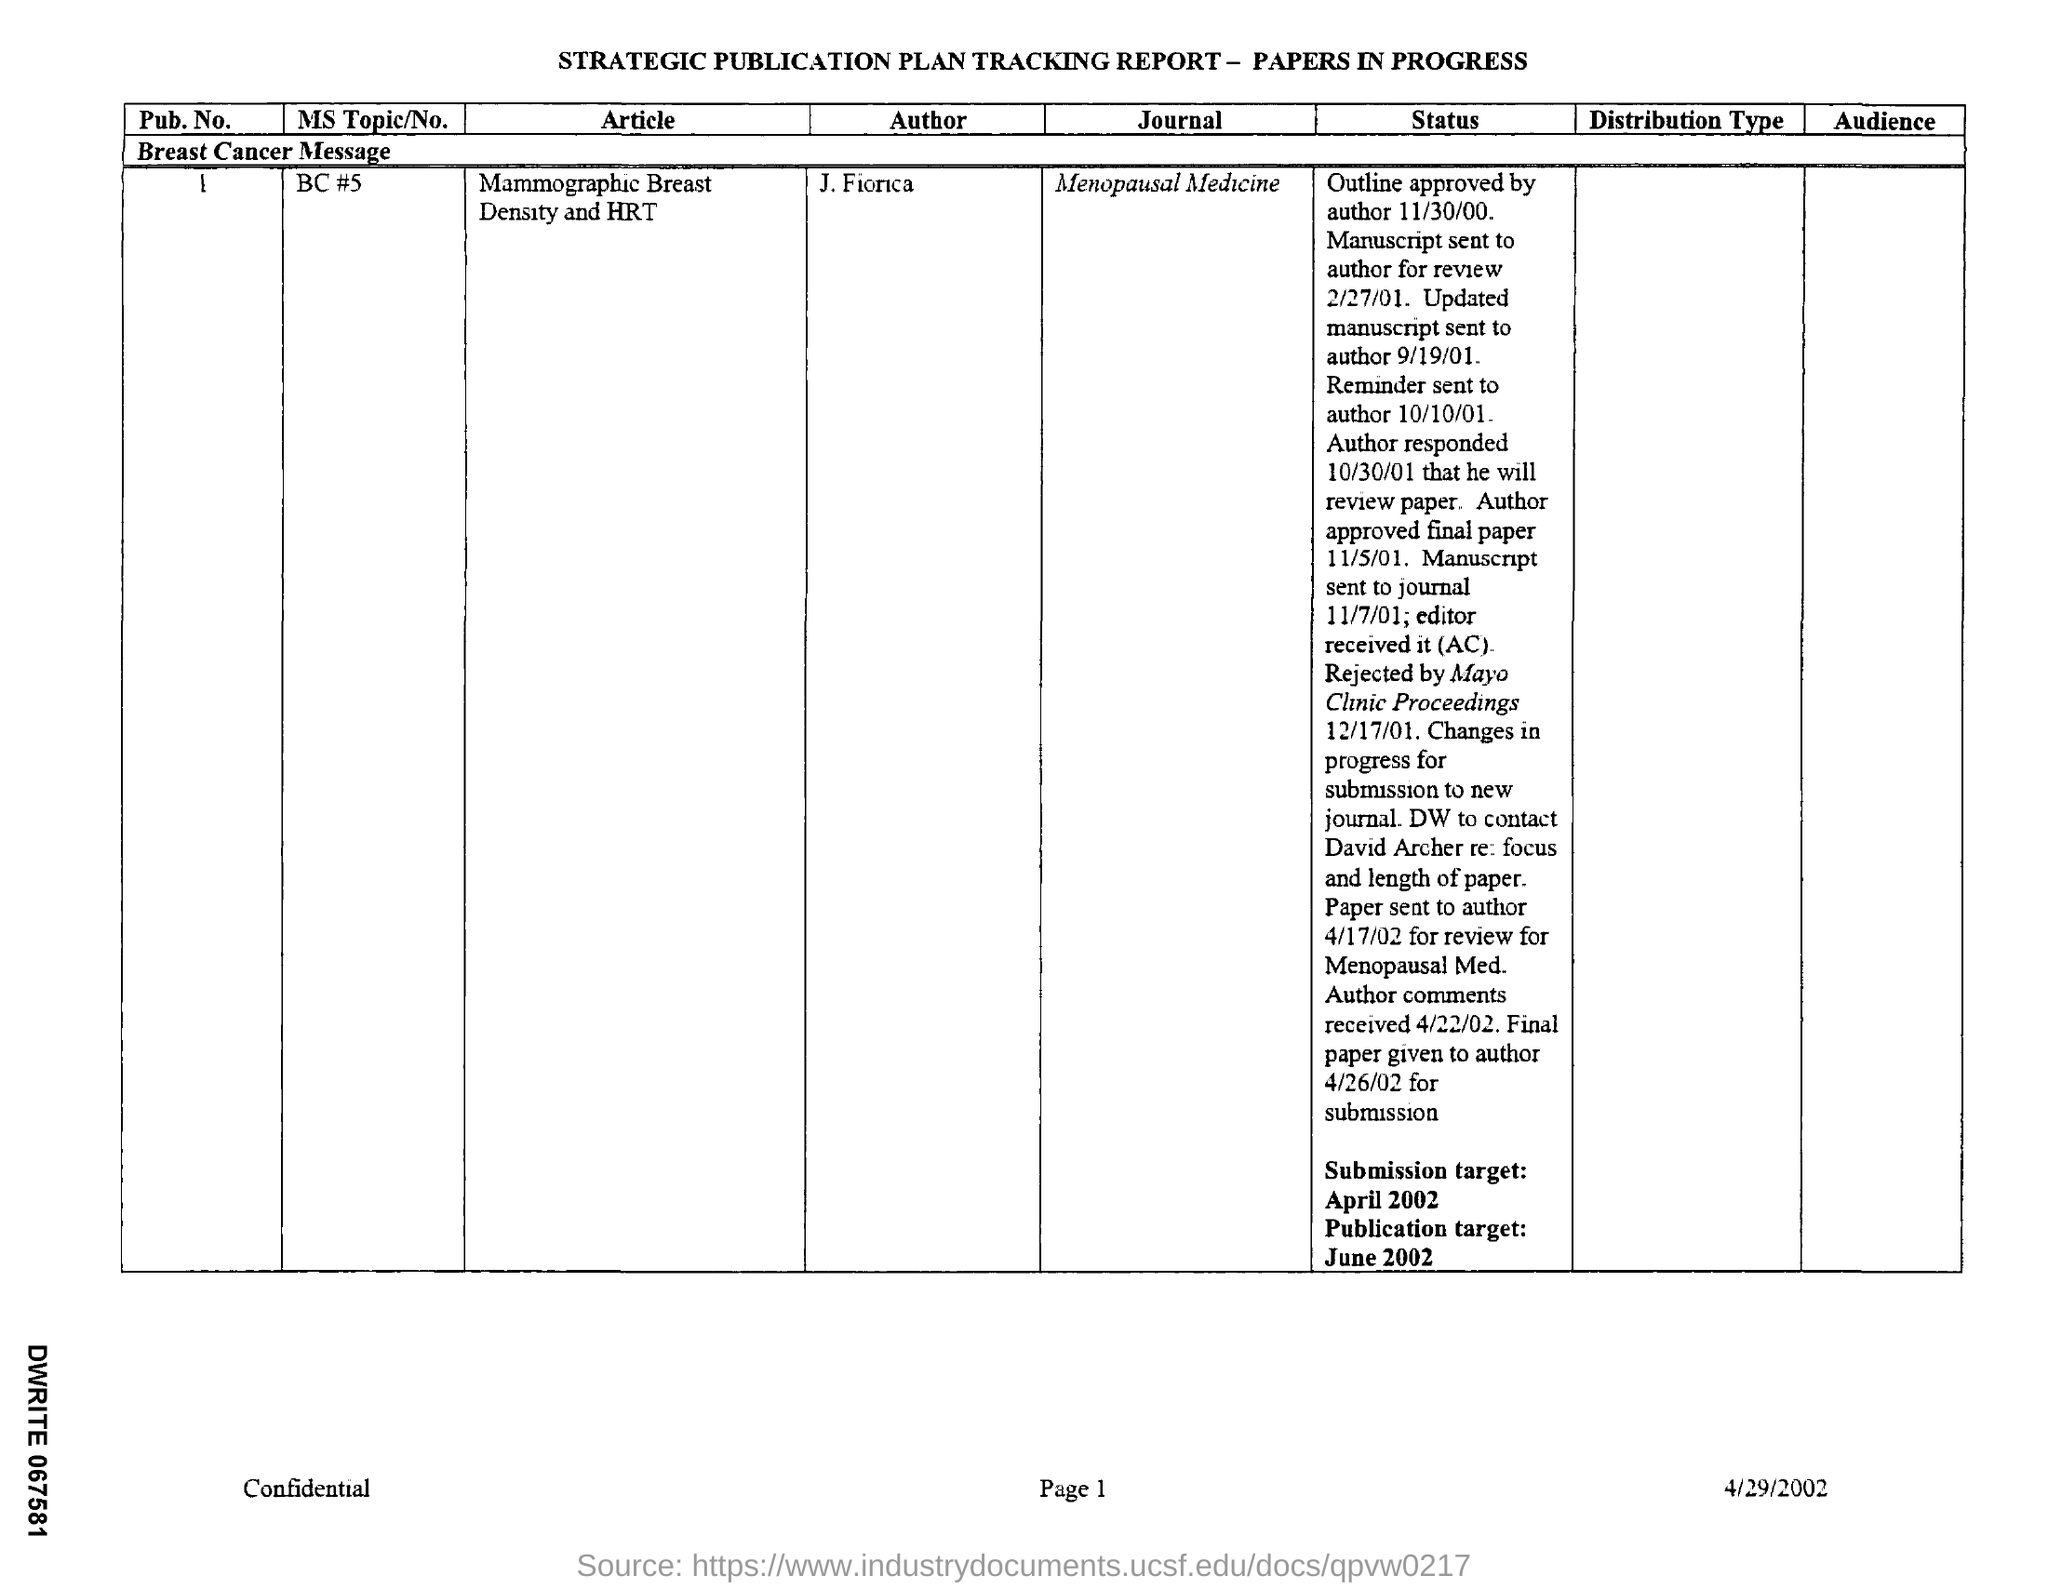What is the name of the Journal?
Offer a terse response. Menopausal Medicine. What is the name of the article?
Offer a terse response. Mammographic Breast Density and HRT. What is the MS Topic/No?
Your response must be concise. BC #5. What is the Pub.No.?
Provide a succinct answer. 1. What is the date mentioned in the document?
Give a very brief answer. 4/29/2002. 